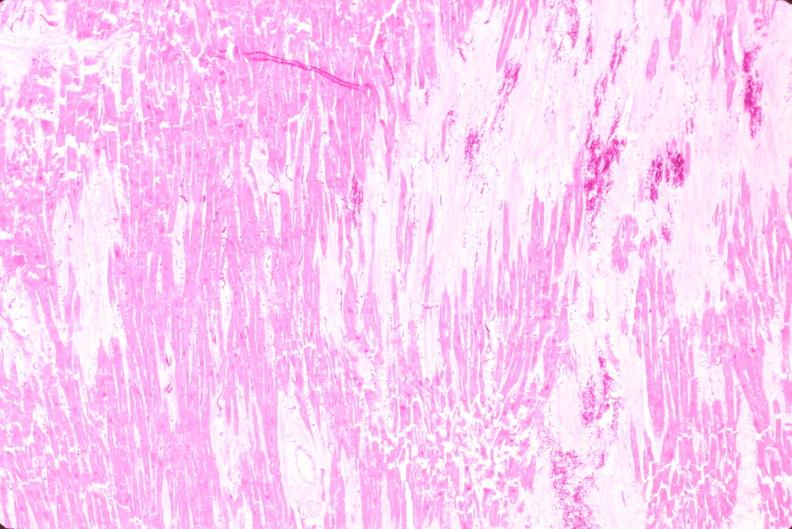where is this in?
Answer the question using a single word or phrase. In heart 